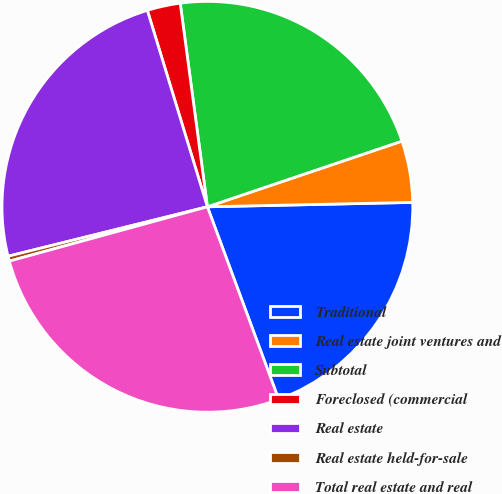<chart> <loc_0><loc_0><loc_500><loc_500><pie_chart><fcel>Traditional<fcel>Real estate joint ventures and<fcel>Subtotal<fcel>Foreclosed (commercial<fcel>Real estate<fcel>Real estate held-for-sale<fcel>Total real estate and real<nl><fcel>19.7%<fcel>4.84%<fcel>21.93%<fcel>2.61%<fcel>24.15%<fcel>0.39%<fcel>26.38%<nl></chart> 